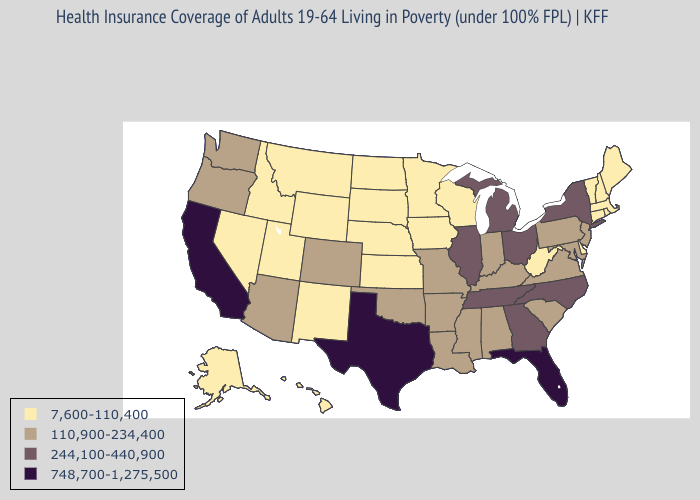Among the states that border Missouri , which have the highest value?
Give a very brief answer. Illinois, Tennessee. Does North Dakota have a lower value than Connecticut?
Quick response, please. No. Among the states that border Tennessee , does Virginia have the lowest value?
Give a very brief answer. Yes. Does Alaska have the lowest value in the USA?
Write a very short answer. Yes. What is the value of New Mexico?
Concise answer only. 7,600-110,400. Which states have the lowest value in the USA?
Give a very brief answer. Alaska, Connecticut, Delaware, Hawaii, Idaho, Iowa, Kansas, Maine, Massachusetts, Minnesota, Montana, Nebraska, Nevada, New Hampshire, New Mexico, North Dakota, Rhode Island, South Dakota, Utah, Vermont, West Virginia, Wisconsin, Wyoming. Does Arkansas have the lowest value in the USA?
Write a very short answer. No. Name the states that have a value in the range 748,700-1,275,500?
Keep it brief. California, Florida, Texas. What is the value of Texas?
Quick response, please. 748,700-1,275,500. Name the states that have a value in the range 110,900-234,400?
Quick response, please. Alabama, Arizona, Arkansas, Colorado, Indiana, Kentucky, Louisiana, Maryland, Mississippi, Missouri, New Jersey, Oklahoma, Oregon, Pennsylvania, South Carolina, Virginia, Washington. Which states have the lowest value in the USA?
Be succinct. Alaska, Connecticut, Delaware, Hawaii, Idaho, Iowa, Kansas, Maine, Massachusetts, Minnesota, Montana, Nebraska, Nevada, New Hampshire, New Mexico, North Dakota, Rhode Island, South Dakota, Utah, Vermont, West Virginia, Wisconsin, Wyoming. What is the lowest value in the Northeast?
Give a very brief answer. 7,600-110,400. What is the value of Arizona?
Short answer required. 110,900-234,400. Does North Carolina have a higher value than Florida?
Answer briefly. No. Name the states that have a value in the range 748,700-1,275,500?
Quick response, please. California, Florida, Texas. 